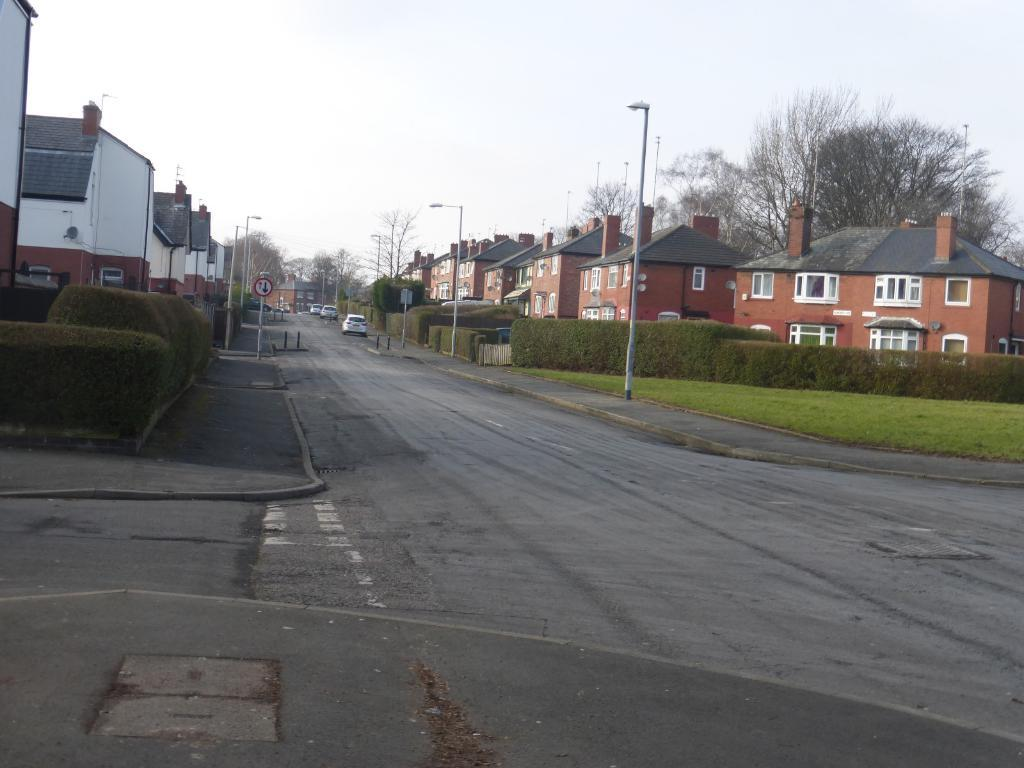What can be seen on the road in the image? There are vehicles on the road in the image. What objects are present in the image that might be used for supporting or guiding? There are poles in the image. What can be seen illuminating the area in the image? There are lights in the image. What type of information might be conveyed by the signboard in the image? The signboard in the image might convey information about directions, warnings, or advertisements. What type of structures can be seen in the image? There are houses in the image. What type of natural elements can be seen in the image? There are plants and trees in the image. What is visible in the background of the image? The sky is visible in the background of the image. How many waves can be seen crashing on the shore in the image? There are no waves present in the image, as it features a scene with vehicles, poles, lights, a signboard, houses, plants, trees, and the sky. What type of clothing is the person wearing on their legs in the image? There are no people or legs visible in the image. 